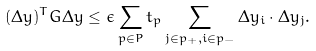<formula> <loc_0><loc_0><loc_500><loc_500>( \Delta { y } ) ^ { T } G \Delta { y } \leq \epsilon \sum _ { p \in P } t _ { p } \sum _ { j \in p _ { + } , i \in p _ { - } } \Delta { y _ { i } } \cdot \Delta { y _ { j } } .</formula> 